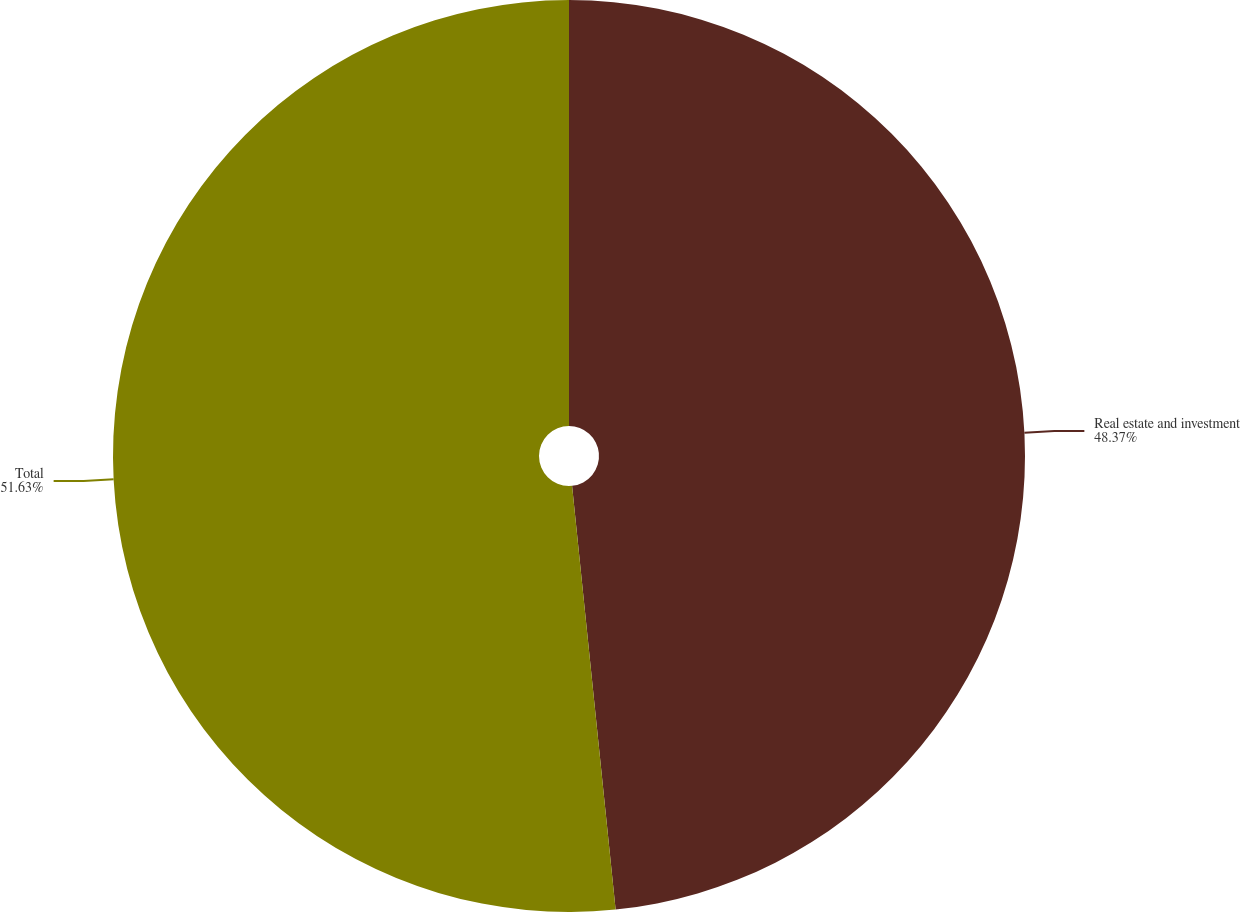<chart> <loc_0><loc_0><loc_500><loc_500><pie_chart><fcel>Real estate and investment<fcel>Total<nl><fcel>48.37%<fcel>51.63%<nl></chart> 